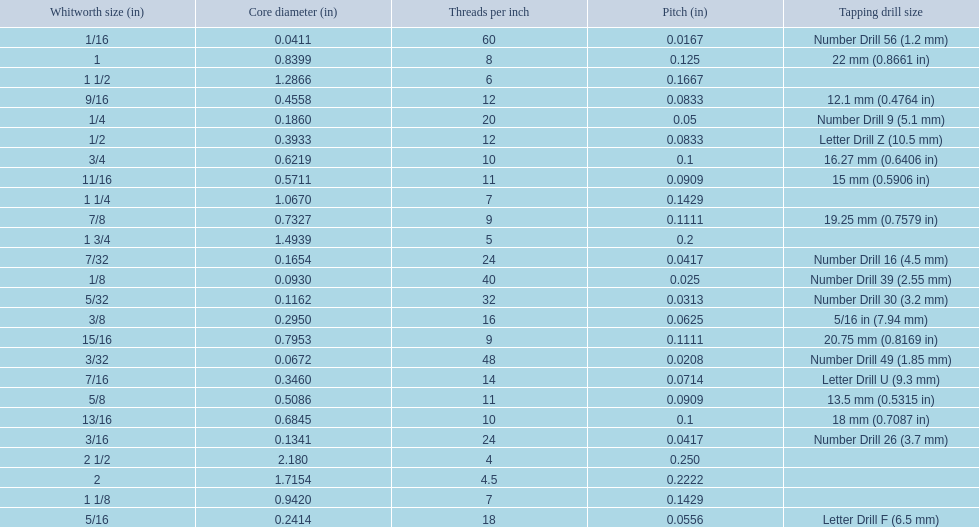A 1/16 whitworth has a core diameter of? 0.0411. Which whiteworth size has the same pitch as a 1/2? 9/16. 3/16 whiteworth has the same number of threads as? 7/32. 